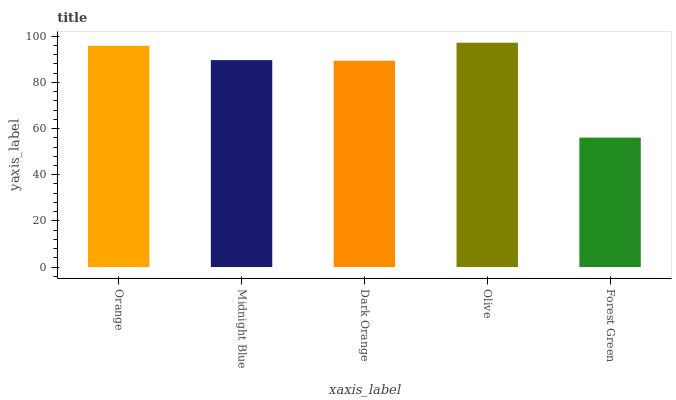Is Forest Green the minimum?
Answer yes or no. Yes. Is Olive the maximum?
Answer yes or no. Yes. Is Midnight Blue the minimum?
Answer yes or no. No. Is Midnight Blue the maximum?
Answer yes or no. No. Is Orange greater than Midnight Blue?
Answer yes or no. Yes. Is Midnight Blue less than Orange?
Answer yes or no. Yes. Is Midnight Blue greater than Orange?
Answer yes or no. No. Is Orange less than Midnight Blue?
Answer yes or no. No. Is Midnight Blue the high median?
Answer yes or no. Yes. Is Midnight Blue the low median?
Answer yes or no. Yes. Is Forest Green the high median?
Answer yes or no. No. Is Dark Orange the low median?
Answer yes or no. No. 